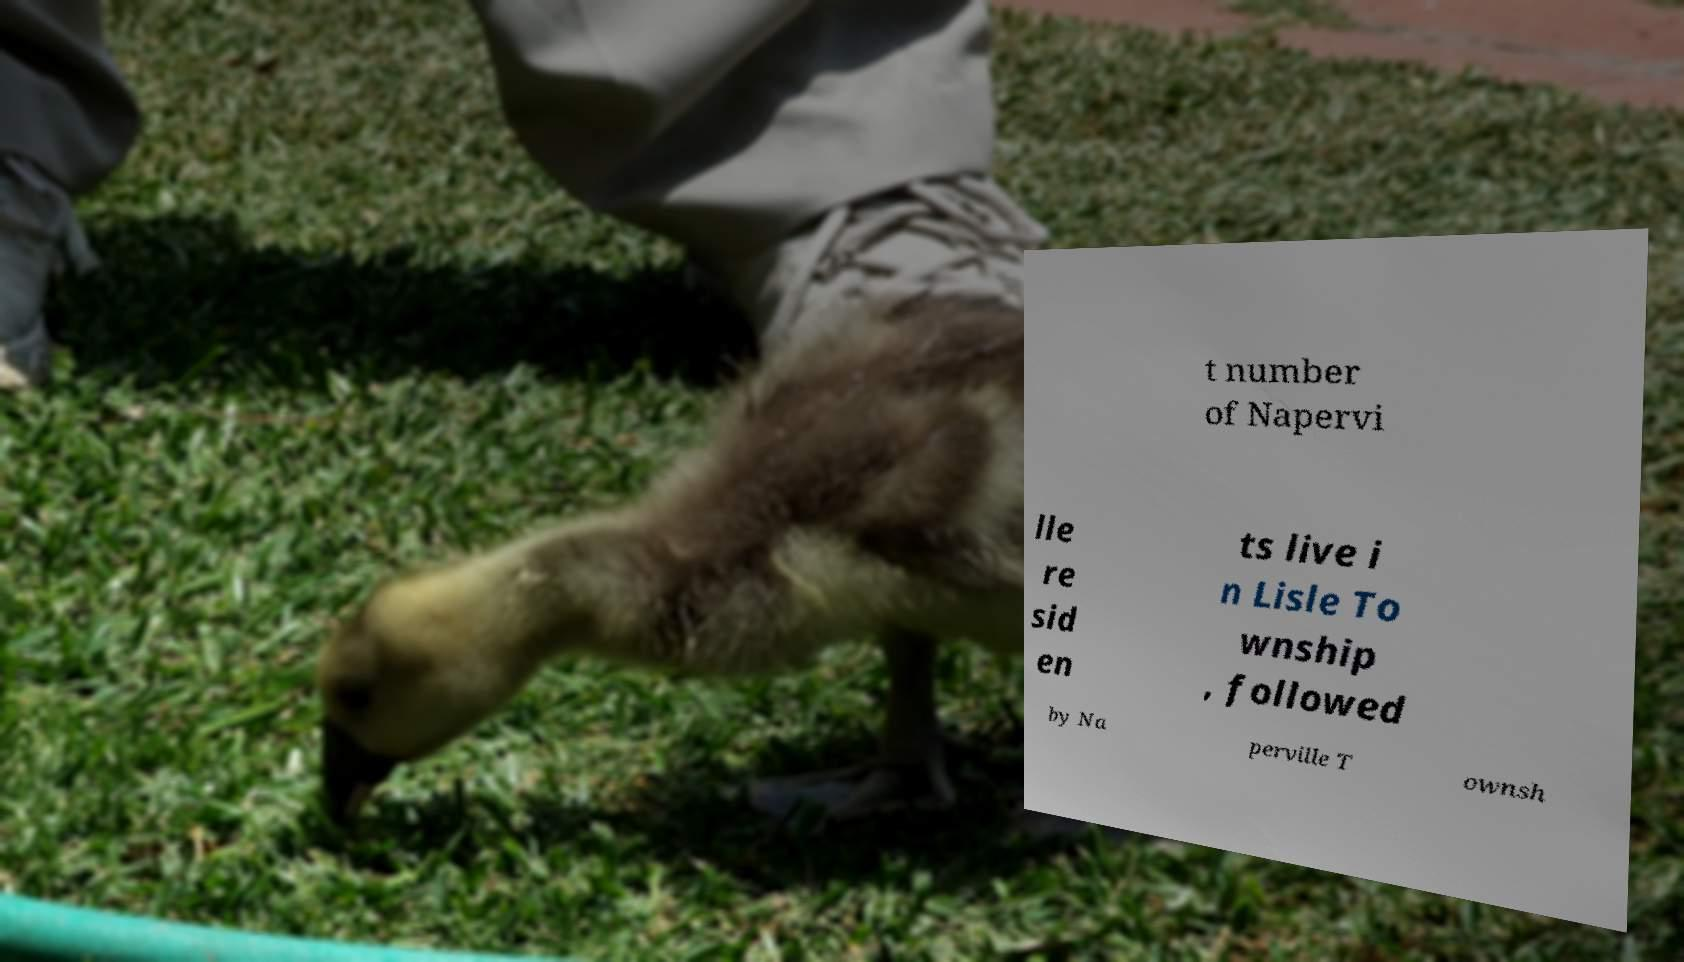There's text embedded in this image that I need extracted. Can you transcribe it verbatim? t number of Napervi lle re sid en ts live i n Lisle To wnship , followed by Na perville T ownsh 